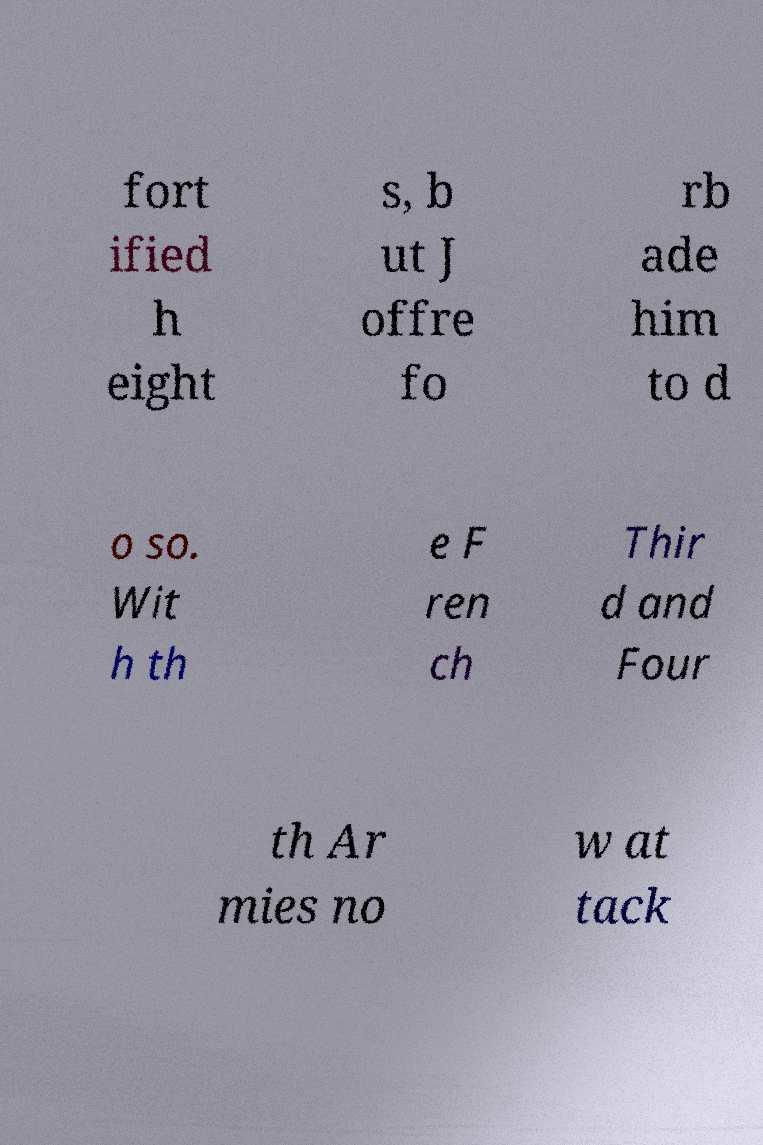Please identify and transcribe the text found in this image. fort ified h eight s, b ut J offre fo rb ade him to d o so. Wit h th e F ren ch Thir d and Four th Ar mies no w at tack 